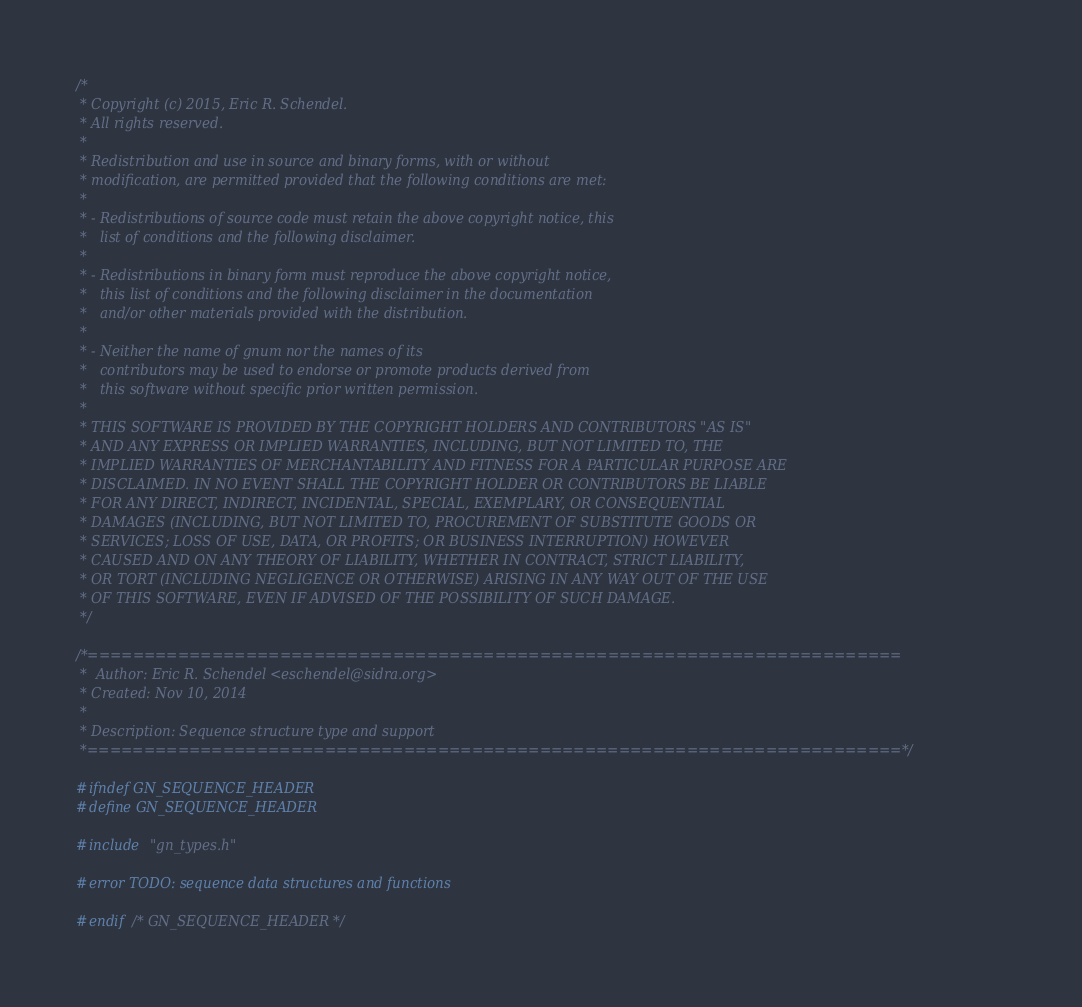<code> <loc_0><loc_0><loc_500><loc_500><_C_>/*
 * Copyright (c) 2015, Eric R. Schendel.
 * All rights reserved.
 *
 * Redistribution and use in source and binary forms, with or without
 * modification, are permitted provided that the following conditions are met:
 *
 * - Redistributions of source code must retain the above copyright notice, this
 *   list of conditions and the following disclaimer.
 *
 * - Redistributions in binary form must reproduce the above copyright notice,
 *   this list of conditions and the following disclaimer in the documentation
 *   and/or other materials provided with the distribution.
 *
 * - Neither the name of gnum nor the names of its
 *   contributors may be used to endorse or promote products derived from
 *   this software without specific prior written permission.
 *
 * THIS SOFTWARE IS PROVIDED BY THE COPYRIGHT HOLDERS AND CONTRIBUTORS "AS IS"
 * AND ANY EXPRESS OR IMPLIED WARRANTIES, INCLUDING, BUT NOT LIMITED TO, THE
 * IMPLIED WARRANTIES OF MERCHANTABILITY AND FITNESS FOR A PARTICULAR PURPOSE ARE
 * DISCLAIMED. IN NO EVENT SHALL THE COPYRIGHT HOLDER OR CONTRIBUTORS BE LIABLE
 * FOR ANY DIRECT, INDIRECT, INCIDENTAL, SPECIAL, EXEMPLARY, OR CONSEQUENTIAL
 * DAMAGES (INCLUDING, BUT NOT LIMITED TO, PROCUREMENT OF SUBSTITUTE GOODS OR
 * SERVICES; LOSS OF USE, DATA, OR PROFITS; OR BUSINESS INTERRUPTION) HOWEVER
 * CAUSED AND ON ANY THEORY OF LIABILITY, WHETHER IN CONTRACT, STRICT LIABILITY,
 * OR TORT (INCLUDING NEGLIGENCE OR OTHERWISE) ARISING IN ANY WAY OUT OF THE USE
 * OF THIS SOFTWARE, EVEN IF ADVISED OF THE POSSIBILITY OF SUCH DAMAGE.
 */

/*========================================================================
 *  Author: Eric R. Schendel <eschendel@sidra.org>
 * Created: Nov 10, 2014
 *
 * Description: Sequence structure type and support
 *========================================================================*/

#ifndef GN_SEQUENCE_HEADER
#define GN_SEQUENCE_HEADER

#include "gn_types.h"

#error TODO: sequence data structures and functions

#endif /* GN_SEQUENCE_HEADER */
</code> 